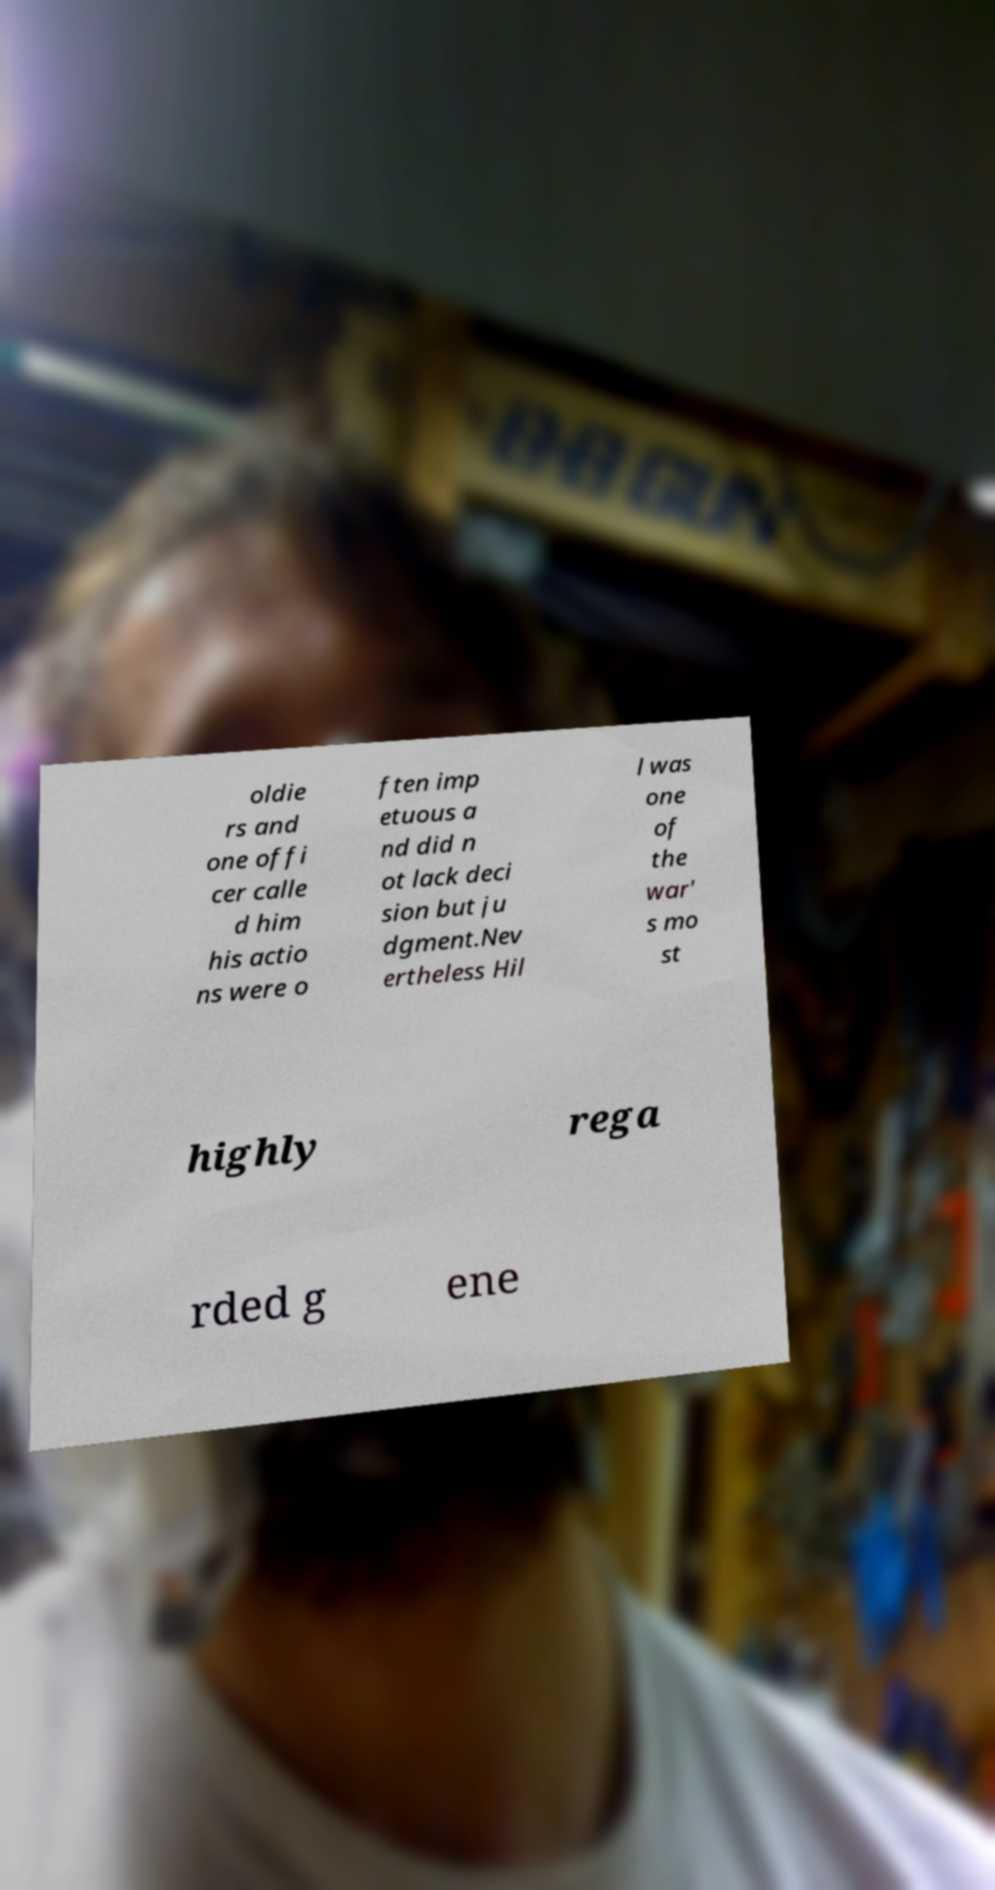For documentation purposes, I need the text within this image transcribed. Could you provide that? oldie rs and one offi cer calle d him his actio ns were o ften imp etuous a nd did n ot lack deci sion but ju dgment.Nev ertheless Hil l was one of the war' s mo st highly rega rded g ene 